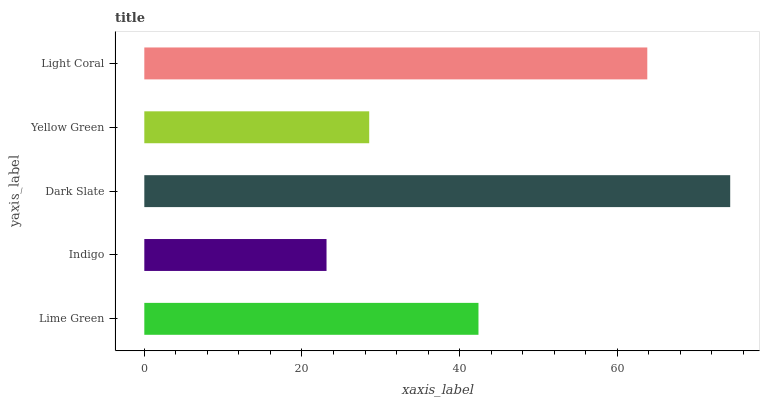Is Indigo the minimum?
Answer yes or no. Yes. Is Dark Slate the maximum?
Answer yes or no. Yes. Is Dark Slate the minimum?
Answer yes or no. No. Is Indigo the maximum?
Answer yes or no. No. Is Dark Slate greater than Indigo?
Answer yes or no. Yes. Is Indigo less than Dark Slate?
Answer yes or no. Yes. Is Indigo greater than Dark Slate?
Answer yes or no. No. Is Dark Slate less than Indigo?
Answer yes or no. No. Is Lime Green the high median?
Answer yes or no. Yes. Is Lime Green the low median?
Answer yes or no. Yes. Is Indigo the high median?
Answer yes or no. No. Is Dark Slate the low median?
Answer yes or no. No. 